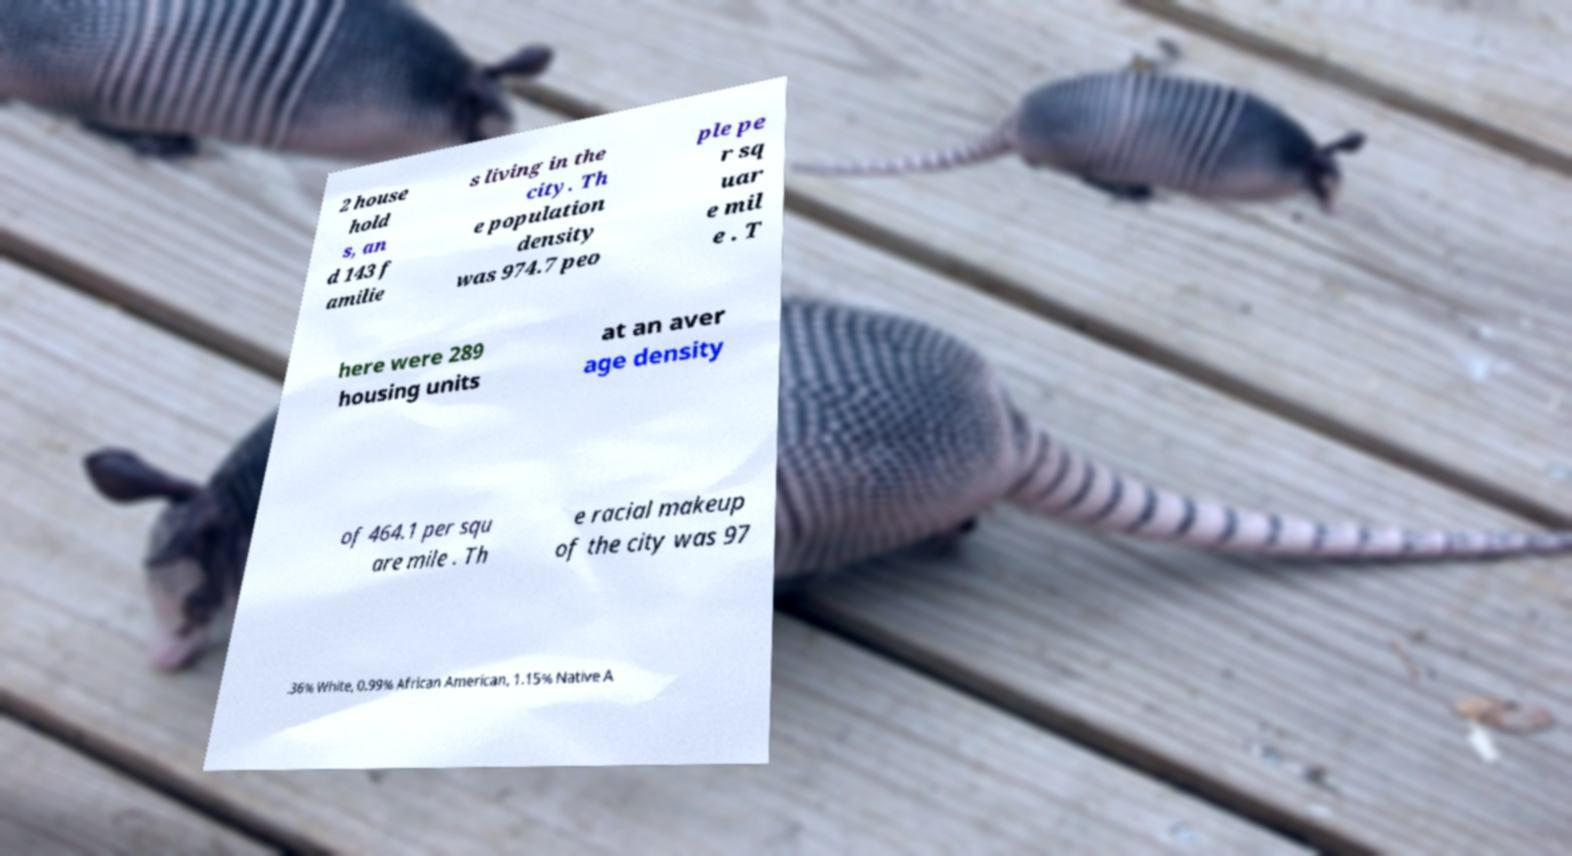Please identify and transcribe the text found in this image. 2 house hold s, an d 143 f amilie s living in the city. Th e population density was 974.7 peo ple pe r sq uar e mil e . T here were 289 housing units at an aver age density of 464.1 per squ are mile . Th e racial makeup of the city was 97 .36% White, 0.99% African American, 1.15% Native A 